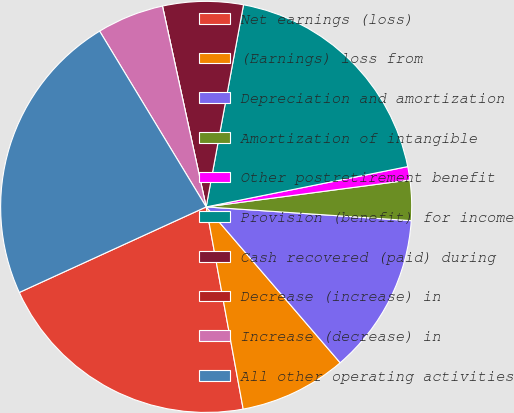Convert chart. <chart><loc_0><loc_0><loc_500><loc_500><pie_chart><fcel>Net earnings (loss)<fcel>(Earnings) loss from<fcel>Depreciation and amortization<fcel>Amortization of intangible<fcel>Other postretirement benefit<fcel>Provision (benefit) for income<fcel>Cash recovered (paid) during<fcel>Decrease (increase) in<fcel>Increase (decrease) in<fcel>All other operating activities<nl><fcel>21.05%<fcel>8.42%<fcel>12.63%<fcel>3.16%<fcel>1.05%<fcel>18.95%<fcel>6.32%<fcel>0.0%<fcel>5.26%<fcel>23.16%<nl></chart> 